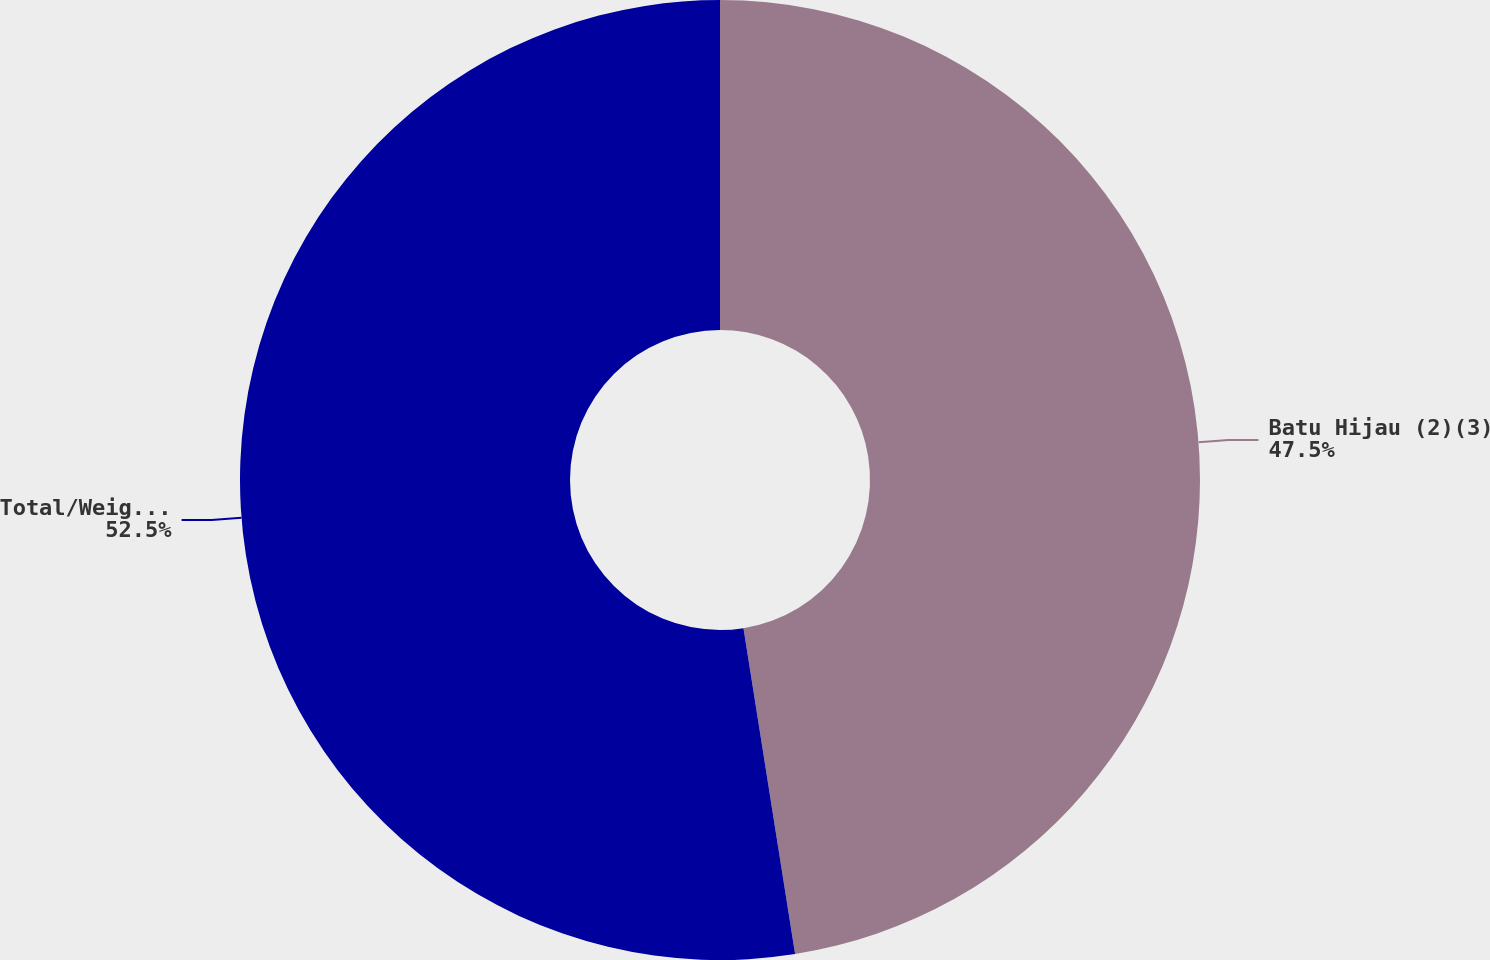<chart> <loc_0><loc_0><loc_500><loc_500><pie_chart><fcel>Batu Hijau (2)(3)<fcel>Total/Weighted-Average<nl><fcel>47.5%<fcel>52.5%<nl></chart> 